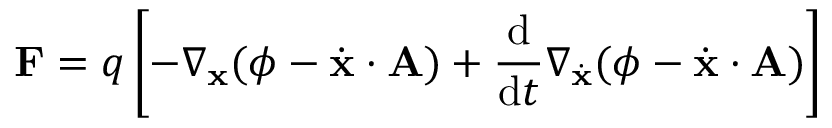Convert formula to latex. <formula><loc_0><loc_0><loc_500><loc_500>F = q \left [ - \nabla _ { x } ( \phi - { \dot { x } } \cdot A ) + { \frac { d } { d t } } \nabla _ { \dot { x } } ( \phi - { \dot { x } } \cdot A ) \right ]</formula> 